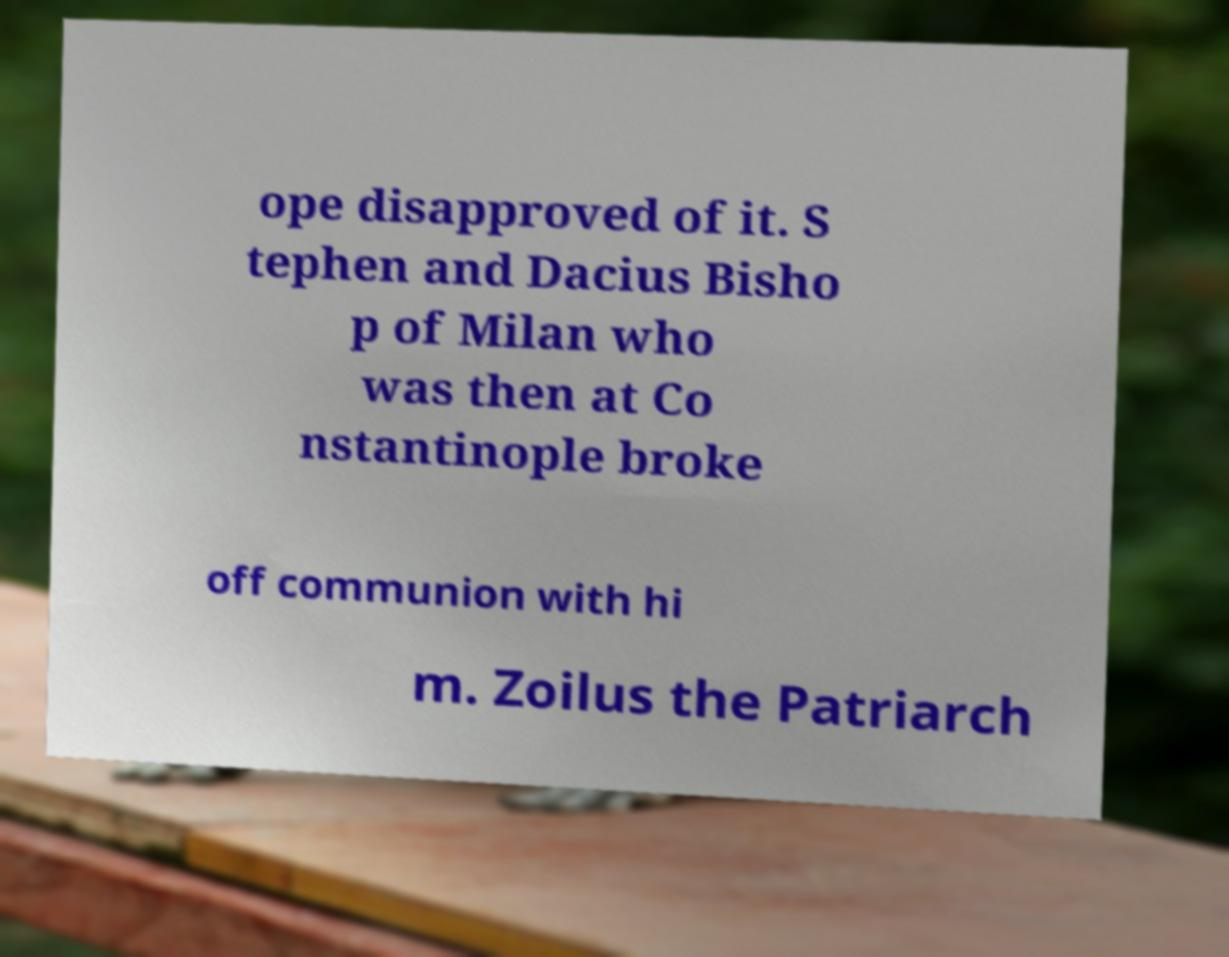Could you assist in decoding the text presented in this image and type it out clearly? ope disapproved of it. S tephen and Dacius Bisho p of Milan who was then at Co nstantinople broke off communion with hi m. Zoilus the Patriarch 